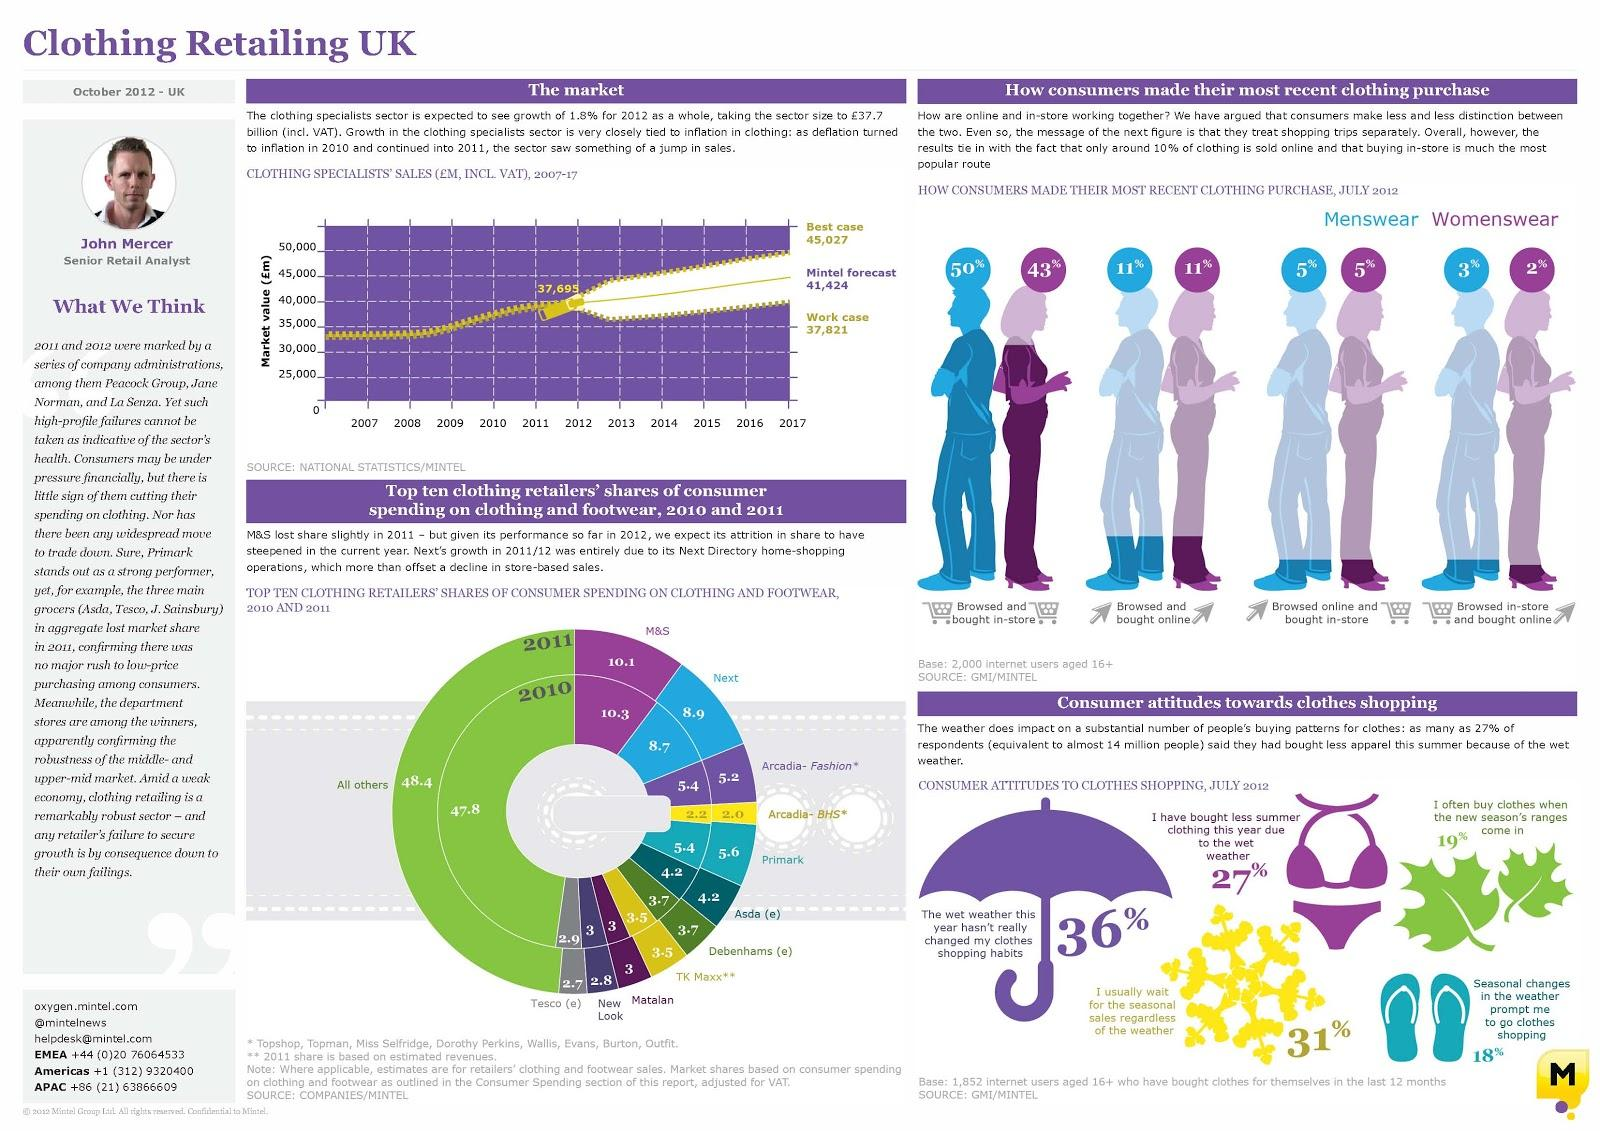Identify some key points in this picture. Asda's consumer spending share in 2011 was 4.2%. In July 2012, 43% of women's clothing was purchased in physical stores by customers. In July 2012, approximately 5% of menswear purchases were made online and then picked up in the store. In 2011, Tesco's share of consumer spending was 2.7%. In July 2012, 11% of women's clothing and accessories were purchased online by customers. 